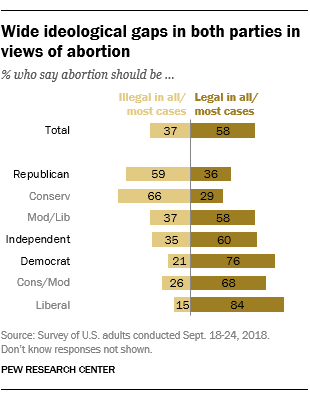Point out several critical features in this image. According to a survey, a significant percentage of liberals believe that abortion should be illegal with 15% of them holding this view. The average of all the bars on the right side is less than the largest light brown bar. 